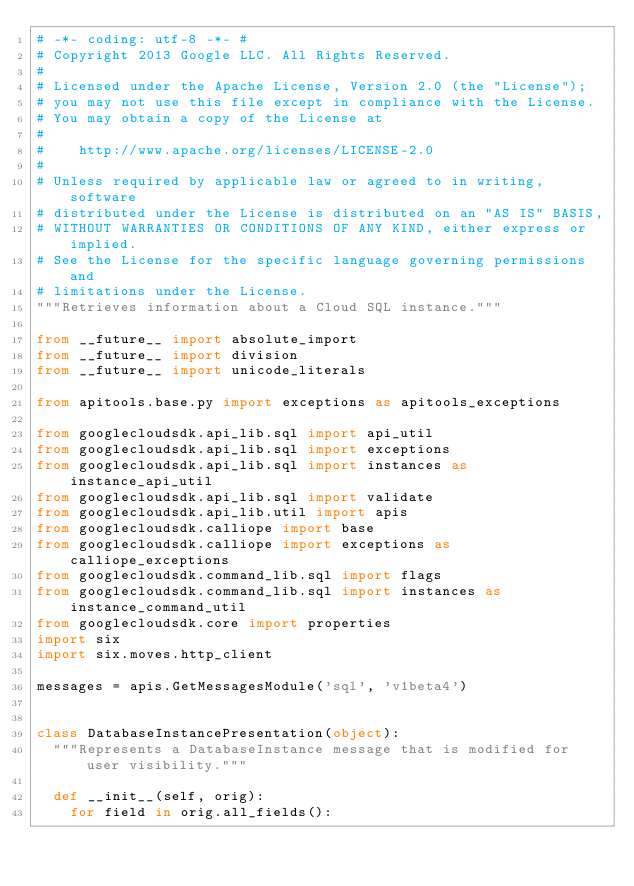Convert code to text. <code><loc_0><loc_0><loc_500><loc_500><_Python_># -*- coding: utf-8 -*- #
# Copyright 2013 Google LLC. All Rights Reserved.
#
# Licensed under the Apache License, Version 2.0 (the "License");
# you may not use this file except in compliance with the License.
# You may obtain a copy of the License at
#
#    http://www.apache.org/licenses/LICENSE-2.0
#
# Unless required by applicable law or agreed to in writing, software
# distributed under the License is distributed on an "AS IS" BASIS,
# WITHOUT WARRANTIES OR CONDITIONS OF ANY KIND, either express or implied.
# See the License for the specific language governing permissions and
# limitations under the License.
"""Retrieves information about a Cloud SQL instance."""

from __future__ import absolute_import
from __future__ import division
from __future__ import unicode_literals

from apitools.base.py import exceptions as apitools_exceptions

from googlecloudsdk.api_lib.sql import api_util
from googlecloudsdk.api_lib.sql import exceptions
from googlecloudsdk.api_lib.sql import instances as instance_api_util
from googlecloudsdk.api_lib.sql import validate
from googlecloudsdk.api_lib.util import apis
from googlecloudsdk.calliope import base
from googlecloudsdk.calliope import exceptions as calliope_exceptions
from googlecloudsdk.command_lib.sql import flags
from googlecloudsdk.command_lib.sql import instances as instance_command_util
from googlecloudsdk.core import properties
import six
import six.moves.http_client

messages = apis.GetMessagesModule('sql', 'v1beta4')


class DatabaseInstancePresentation(object):
  """Represents a DatabaseInstance message that is modified for user visibility."""

  def __init__(self, orig):
    for field in orig.all_fields():</code> 